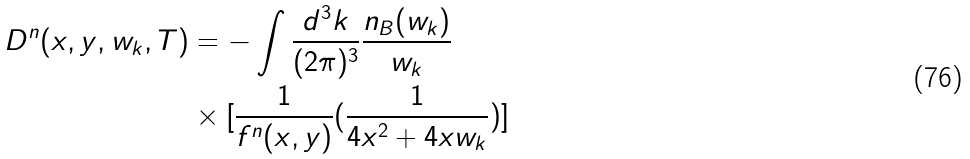Convert formula to latex. <formula><loc_0><loc_0><loc_500><loc_500>D ^ { n } ( x , y , w _ { k } , T ) & = - \int \frac { d ^ { 3 } k } { ( 2 \pi ) ^ { 3 } } \frac { n _ { B } ( w _ { k } ) } { w _ { k } } \\ & \times [ \frac { 1 } { f ^ { n } ( x , y ) } ( \frac { 1 } { 4 x ^ { 2 } + 4 x w _ { k } } ) ]</formula> 